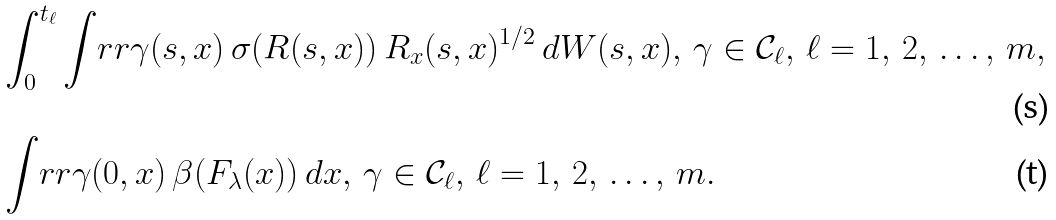Convert formula to latex. <formula><loc_0><loc_0><loc_500><loc_500>& \int _ { 0 } ^ { t _ { \ell } } \int _ { \ } r r \gamma ( s , x ) \, \sigma ( R ( s , x ) ) \, R _ { x } ( s , x ) ^ { 1 / 2 } \, d W ( s , x ) , \, \gamma \in { \mathcal { C } } _ { \ell } , \, \ell = 1 , \, 2 , \, \dots , \, m , \\ & \int _ { \ } r r \gamma ( 0 , x ) \, \beta ( F _ { \lambda } ( x ) ) \, d x , \, \gamma \in { \mathcal { C } } _ { \ell } , \, \ell = 1 , \, 2 , \, \dots , \, m .</formula> 